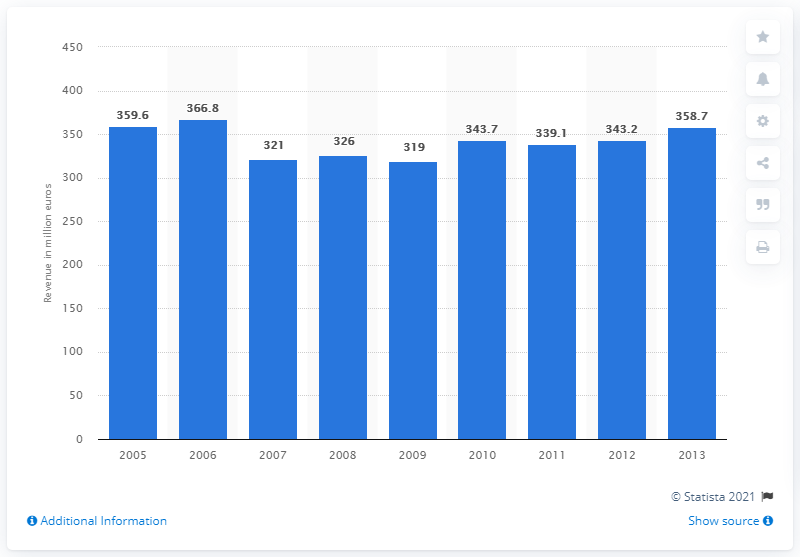What was the revenue of Head N.V. in 2006? In 2006, the sports equipment company Head N.V. reported a revenue of 366.8 million euros, showcasing their financial performance within that fiscal year. 